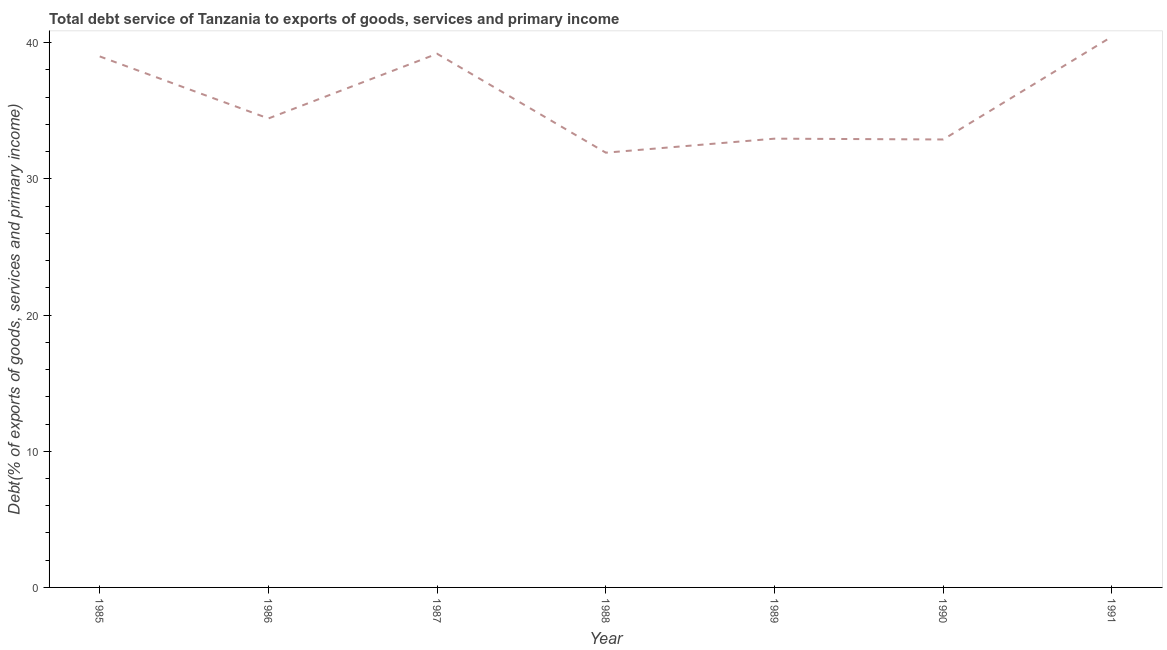What is the total debt service in 1985?
Give a very brief answer. 38.99. Across all years, what is the maximum total debt service?
Give a very brief answer. 40.45. Across all years, what is the minimum total debt service?
Your response must be concise. 31.92. In which year was the total debt service maximum?
Offer a very short reply. 1991. In which year was the total debt service minimum?
Provide a short and direct response. 1988. What is the sum of the total debt service?
Provide a succinct answer. 250.83. What is the difference between the total debt service in 1988 and 1990?
Your answer should be very brief. -0.97. What is the average total debt service per year?
Your response must be concise. 35.83. What is the median total debt service?
Give a very brief answer. 34.44. Do a majority of the years between 1990 and 1988 (inclusive) have total debt service greater than 16 %?
Your answer should be compact. No. What is the ratio of the total debt service in 1986 to that in 1987?
Your answer should be compact. 0.88. Is the total debt service in 1986 less than that in 1991?
Give a very brief answer. Yes. What is the difference between the highest and the second highest total debt service?
Make the answer very short. 1.26. What is the difference between the highest and the lowest total debt service?
Make the answer very short. 8.52. Does the total debt service monotonically increase over the years?
Provide a short and direct response. No. How many years are there in the graph?
Provide a succinct answer. 7. What is the difference between two consecutive major ticks on the Y-axis?
Keep it short and to the point. 10. Does the graph contain any zero values?
Provide a succinct answer. No. What is the title of the graph?
Offer a terse response. Total debt service of Tanzania to exports of goods, services and primary income. What is the label or title of the Y-axis?
Provide a succinct answer. Debt(% of exports of goods, services and primary income). What is the Debt(% of exports of goods, services and primary income) in 1985?
Give a very brief answer. 38.99. What is the Debt(% of exports of goods, services and primary income) of 1986?
Make the answer very short. 34.44. What is the Debt(% of exports of goods, services and primary income) of 1987?
Offer a very short reply. 39.19. What is the Debt(% of exports of goods, services and primary income) in 1988?
Keep it short and to the point. 31.92. What is the Debt(% of exports of goods, services and primary income) of 1989?
Your answer should be compact. 32.95. What is the Debt(% of exports of goods, services and primary income) of 1990?
Your answer should be very brief. 32.89. What is the Debt(% of exports of goods, services and primary income) in 1991?
Give a very brief answer. 40.45. What is the difference between the Debt(% of exports of goods, services and primary income) in 1985 and 1986?
Your answer should be compact. 4.56. What is the difference between the Debt(% of exports of goods, services and primary income) in 1985 and 1987?
Offer a terse response. -0.2. What is the difference between the Debt(% of exports of goods, services and primary income) in 1985 and 1988?
Make the answer very short. 7.07. What is the difference between the Debt(% of exports of goods, services and primary income) in 1985 and 1989?
Provide a succinct answer. 6.04. What is the difference between the Debt(% of exports of goods, services and primary income) in 1985 and 1990?
Your answer should be compact. 6.1. What is the difference between the Debt(% of exports of goods, services and primary income) in 1985 and 1991?
Give a very brief answer. -1.45. What is the difference between the Debt(% of exports of goods, services and primary income) in 1986 and 1987?
Your response must be concise. -4.75. What is the difference between the Debt(% of exports of goods, services and primary income) in 1986 and 1988?
Your answer should be very brief. 2.51. What is the difference between the Debt(% of exports of goods, services and primary income) in 1986 and 1989?
Offer a terse response. 1.48. What is the difference between the Debt(% of exports of goods, services and primary income) in 1986 and 1990?
Your answer should be compact. 1.54. What is the difference between the Debt(% of exports of goods, services and primary income) in 1986 and 1991?
Your answer should be very brief. -6.01. What is the difference between the Debt(% of exports of goods, services and primary income) in 1987 and 1988?
Your response must be concise. 7.26. What is the difference between the Debt(% of exports of goods, services and primary income) in 1987 and 1989?
Give a very brief answer. 6.23. What is the difference between the Debt(% of exports of goods, services and primary income) in 1987 and 1990?
Provide a short and direct response. 6.29. What is the difference between the Debt(% of exports of goods, services and primary income) in 1987 and 1991?
Provide a succinct answer. -1.26. What is the difference between the Debt(% of exports of goods, services and primary income) in 1988 and 1989?
Offer a terse response. -1.03. What is the difference between the Debt(% of exports of goods, services and primary income) in 1988 and 1990?
Offer a very short reply. -0.97. What is the difference between the Debt(% of exports of goods, services and primary income) in 1988 and 1991?
Your answer should be compact. -8.52. What is the difference between the Debt(% of exports of goods, services and primary income) in 1989 and 1990?
Give a very brief answer. 0.06. What is the difference between the Debt(% of exports of goods, services and primary income) in 1989 and 1991?
Offer a terse response. -7.49. What is the difference between the Debt(% of exports of goods, services and primary income) in 1990 and 1991?
Offer a terse response. -7.55. What is the ratio of the Debt(% of exports of goods, services and primary income) in 1985 to that in 1986?
Your answer should be very brief. 1.13. What is the ratio of the Debt(% of exports of goods, services and primary income) in 1985 to that in 1988?
Offer a terse response. 1.22. What is the ratio of the Debt(% of exports of goods, services and primary income) in 1985 to that in 1989?
Provide a succinct answer. 1.18. What is the ratio of the Debt(% of exports of goods, services and primary income) in 1985 to that in 1990?
Provide a short and direct response. 1.19. What is the ratio of the Debt(% of exports of goods, services and primary income) in 1986 to that in 1987?
Keep it short and to the point. 0.88. What is the ratio of the Debt(% of exports of goods, services and primary income) in 1986 to that in 1988?
Ensure brevity in your answer.  1.08. What is the ratio of the Debt(% of exports of goods, services and primary income) in 1986 to that in 1989?
Offer a very short reply. 1.04. What is the ratio of the Debt(% of exports of goods, services and primary income) in 1986 to that in 1990?
Your answer should be compact. 1.05. What is the ratio of the Debt(% of exports of goods, services and primary income) in 1986 to that in 1991?
Keep it short and to the point. 0.85. What is the ratio of the Debt(% of exports of goods, services and primary income) in 1987 to that in 1988?
Your response must be concise. 1.23. What is the ratio of the Debt(% of exports of goods, services and primary income) in 1987 to that in 1989?
Offer a terse response. 1.19. What is the ratio of the Debt(% of exports of goods, services and primary income) in 1987 to that in 1990?
Your response must be concise. 1.19. What is the ratio of the Debt(% of exports of goods, services and primary income) in 1988 to that in 1991?
Your response must be concise. 0.79. What is the ratio of the Debt(% of exports of goods, services and primary income) in 1989 to that in 1990?
Offer a very short reply. 1. What is the ratio of the Debt(% of exports of goods, services and primary income) in 1989 to that in 1991?
Your response must be concise. 0.81. What is the ratio of the Debt(% of exports of goods, services and primary income) in 1990 to that in 1991?
Ensure brevity in your answer.  0.81. 